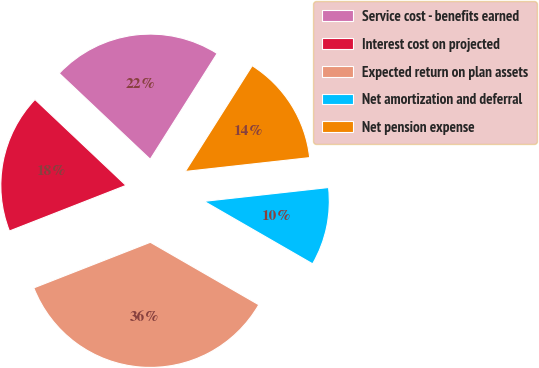Convert chart to OTSL. <chart><loc_0><loc_0><loc_500><loc_500><pie_chart><fcel>Service cost - benefits earned<fcel>Interest cost on projected<fcel>Expected return on plan assets<fcel>Net amortization and deferral<fcel>Net pension expense<nl><fcel>21.93%<fcel>17.98%<fcel>35.74%<fcel>10.08%<fcel>14.26%<nl></chart> 